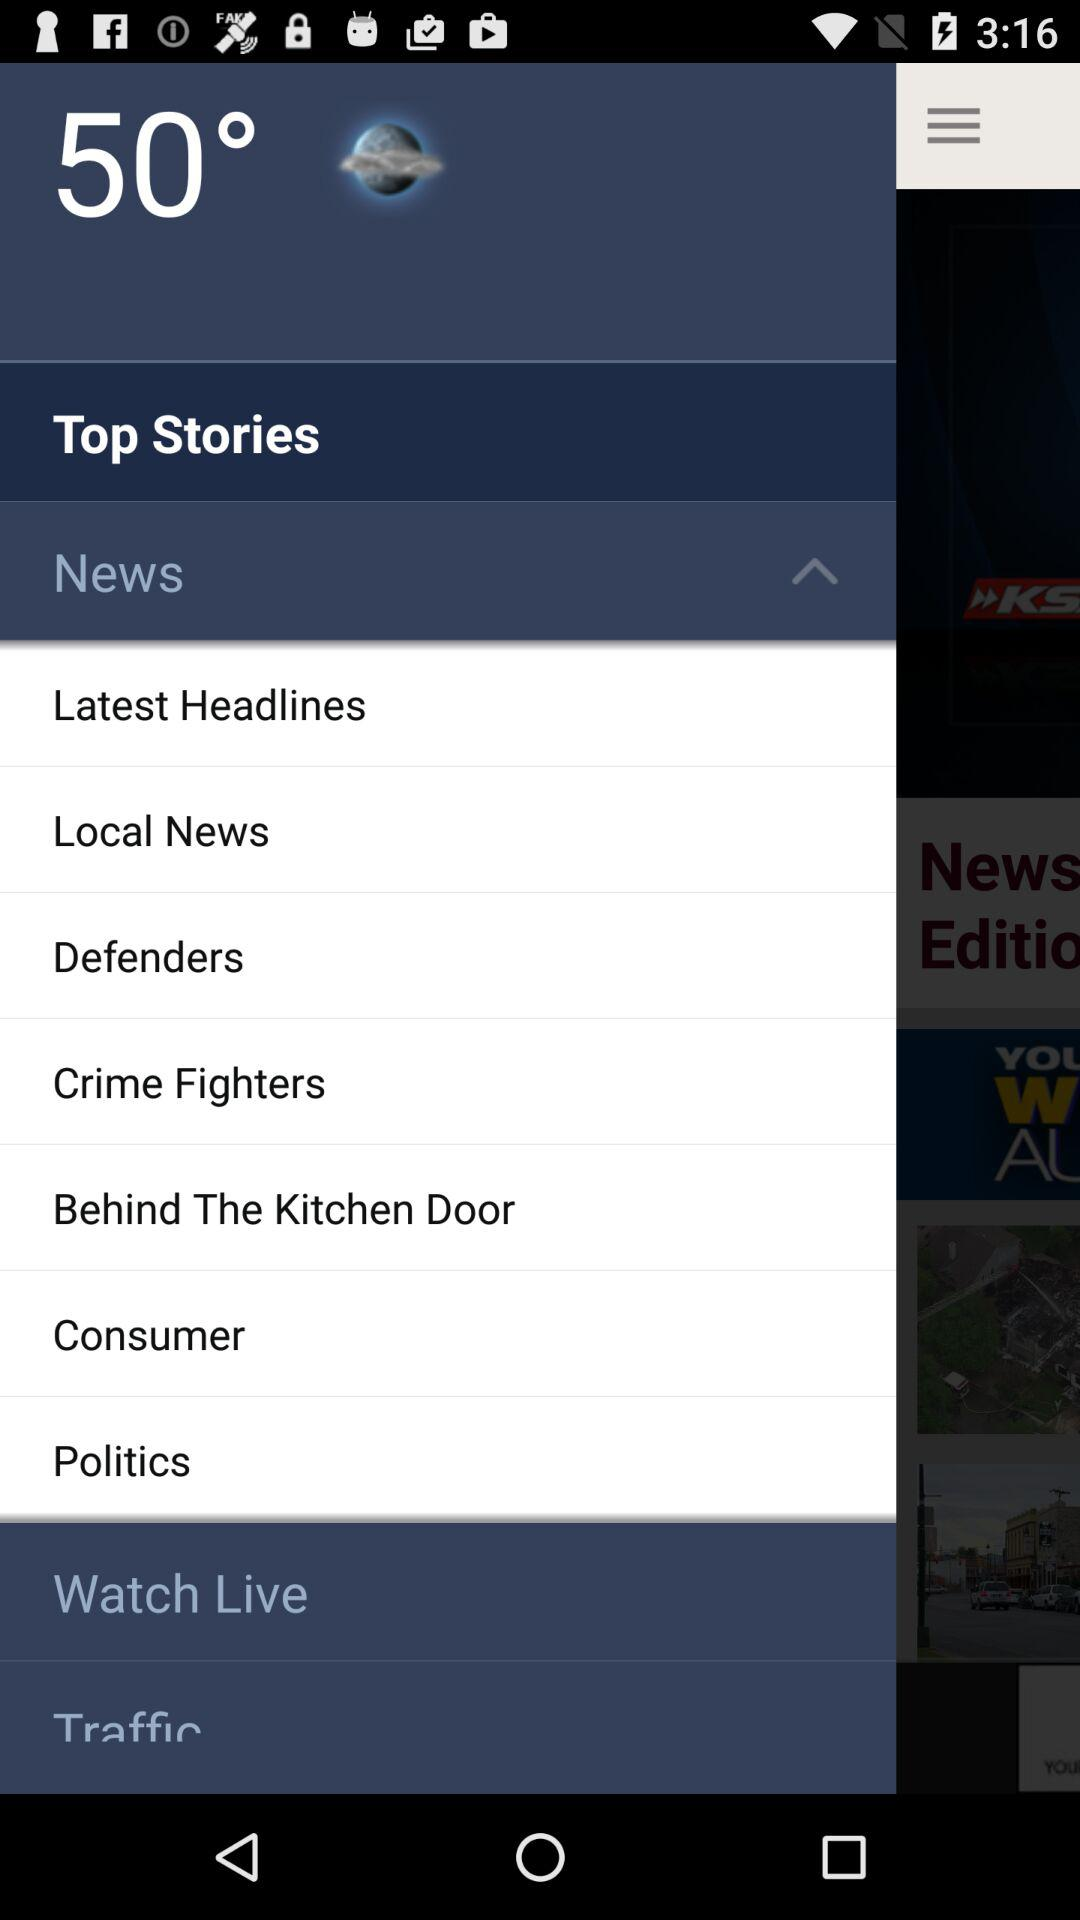How many notifications are there in "Politics"?
When the provided information is insufficient, respond with <no answer>. <no answer> 